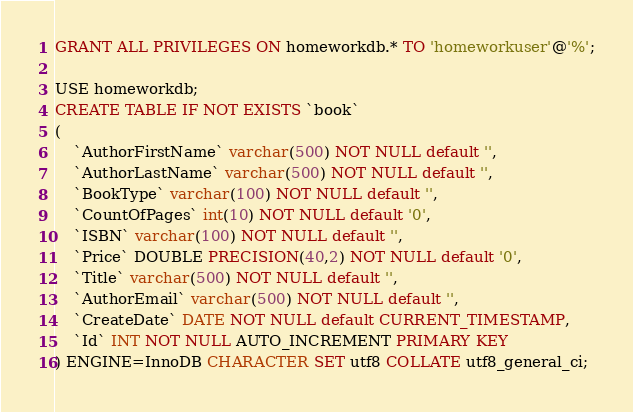Convert code to text. <code><loc_0><loc_0><loc_500><loc_500><_SQL_>GRANT ALL PRIVILEGES ON homeworkdb.* TO 'homeworkuser'@'%';

USE homeworkdb;
CREATE TABLE IF NOT EXISTS `book`
(
    `AuthorFirstName` varchar(500) NOT NULL default '',
    `AuthorLastName` varchar(500) NOT NULL default '',
    `BookType` varchar(100) NOT NULL default '',
    `CountOfPages` int(10) NOT NULL default '0',
    `ISBN` varchar(100) NOT NULL default '',
    `Price` DOUBLE PRECISION(40,2) NOT NULL default '0',
    `Title` varchar(500) NOT NULL default '',
    `AuthorEmail` varchar(500) NOT NULL default '',
    `CreateDate` DATE NOT NULL default CURRENT_TIMESTAMP,
    `Id` INT NOT NULL AUTO_INCREMENT PRIMARY KEY
) ENGINE=InnoDB CHARACTER SET utf8 COLLATE utf8_general_ci;</code> 